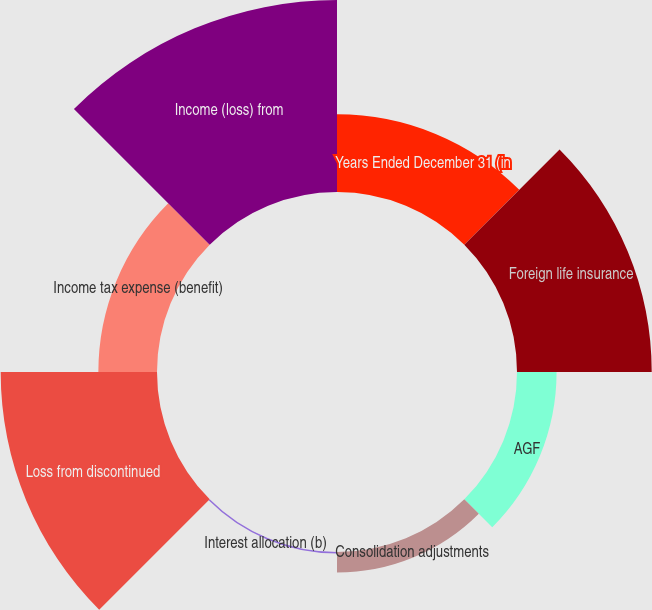<chart> <loc_0><loc_0><loc_500><loc_500><pie_chart><fcel>Years Ended December 31 (in<fcel>Foreign life insurance<fcel>AGF<fcel>Consolidation adjustments<fcel>Interest allocation (b)<fcel>Loss from discontinued<fcel>Income tax expense (benefit)<fcel>Income (loss) from<nl><fcel>11.41%<fcel>19.78%<fcel>5.81%<fcel>3.02%<fcel>0.22%<fcel>22.95%<fcel>8.61%<fcel>28.19%<nl></chart> 